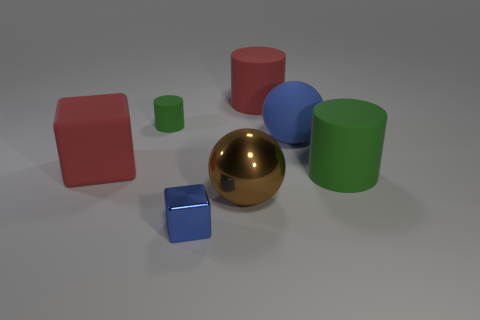Subtract all red blocks. How many green cylinders are left? 2 Subtract all red cylinders. How many cylinders are left? 2 Add 2 large red matte blocks. How many objects exist? 9 Subtract all spheres. How many objects are left? 5 Subtract 0 purple blocks. How many objects are left? 7 Subtract all gray cylinders. Subtract all red blocks. How many cylinders are left? 3 Subtract all big brown balls. Subtract all red matte cubes. How many objects are left? 5 Add 2 green rubber objects. How many green rubber objects are left? 4 Add 3 matte blocks. How many matte blocks exist? 4 